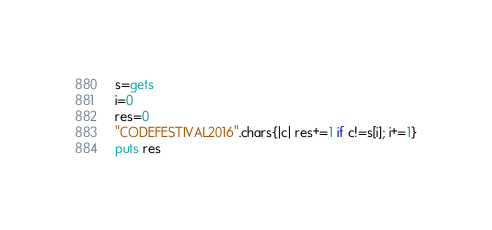<code> <loc_0><loc_0><loc_500><loc_500><_Ruby_>s=gets
i=0
res=0
"CODEFESTIVAL2016".chars{|c| res+=1 if c!=s[i]; i+=1}
puts res
</code> 